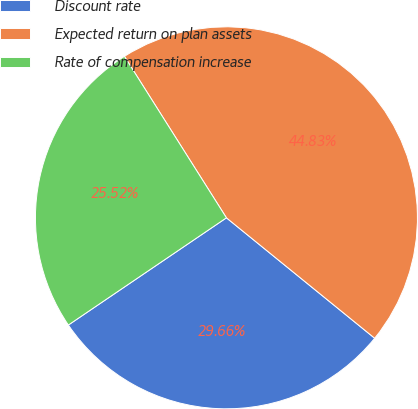Convert chart to OTSL. <chart><loc_0><loc_0><loc_500><loc_500><pie_chart><fcel>Discount rate<fcel>Expected return on plan assets<fcel>Rate of compensation increase<nl><fcel>29.66%<fcel>44.83%<fcel>25.52%<nl></chart> 